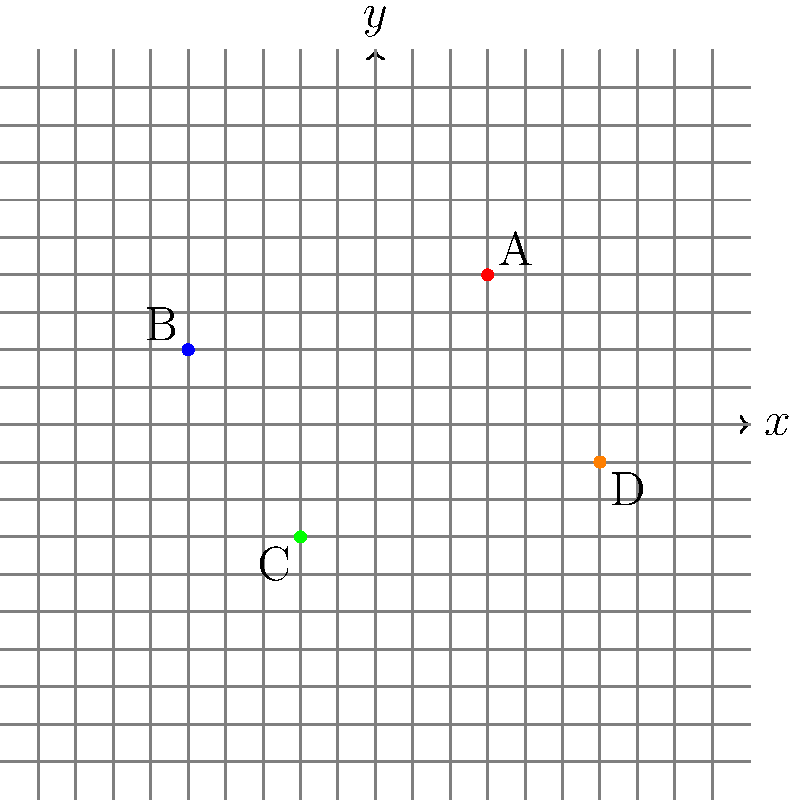In a top-down retro-style adventure game, you're collecting rare items scattered across the map. The game uses a coordinate system to track item locations. Given the coordinates of four collectible items: A(3,4), B(-5,2), C(-2,-3), and D(6,-1), which item is located in the fourth quadrant of the coordinate plane? To solve this problem, we need to understand the quadrants of the coordinate plane and how to identify them:

1. First Quadrant: Both x and y coordinates are positive (+,+)
2. Second Quadrant: x is negative, y is positive (-,+)
3. Third Quadrant: Both x and y coordinates are negative (-,-)
4. Fourth Quadrant: x is positive, y is negative (+,-)

Now, let's analyze each item's coordinates:

1. Item A(3,4): Both coordinates are positive, so it's in the first quadrant.
2. Item B(-5,2): x is negative, y is positive, so it's in the second quadrant.
3. Item C(-2,-3): Both coordinates are negative, so it's in the third quadrant.
4. Item D(6,-1): x is positive, y is negative, so it's in the fourth quadrant.

Therefore, Item D is the only item located in the fourth quadrant.
Answer: D 